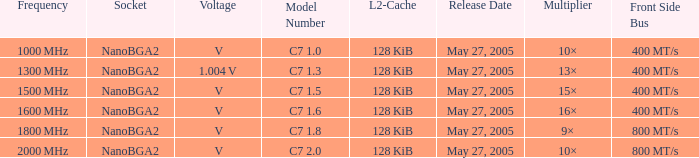8? May 27, 2005. 